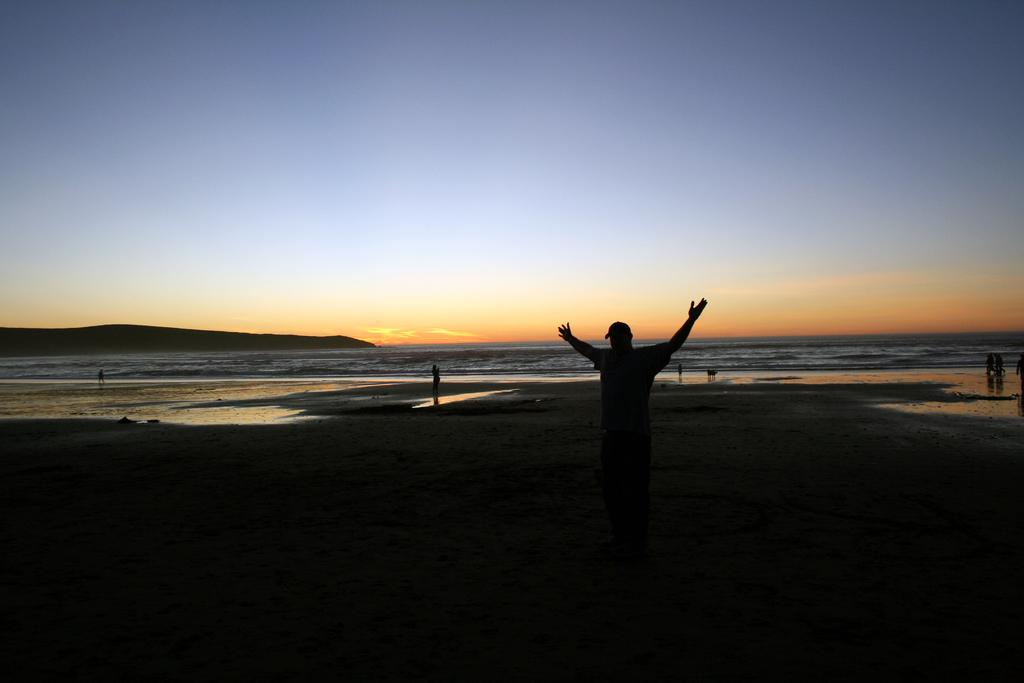What is the main subject of the image? There is a person standing in the center of the image. What is the person wearing on their head? The person is wearing a cap. What can be seen in the background of the image? Water and the sky are visible in the background of the image. What type of surface is at the bottom of the image? There is sand at the bottom of the image. What type of chalk is being used to write on the sand in the image? There is no chalk or writing present in the image; it features a person standing in the center with a cap, water and sky in the background, and sand at the bottom. 